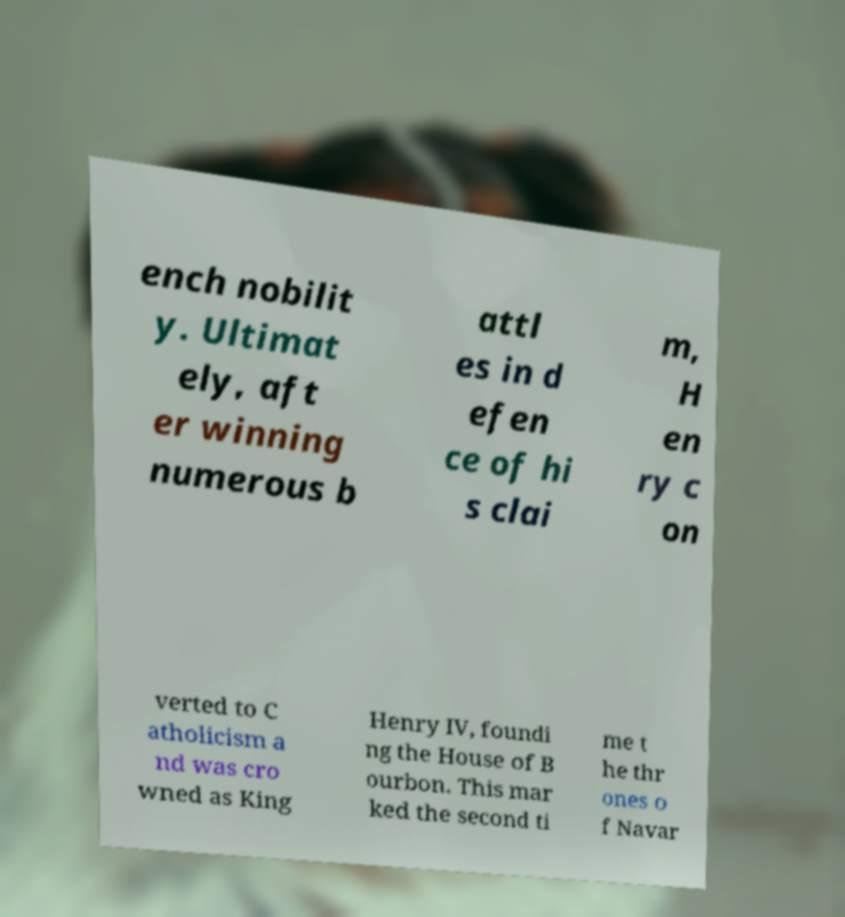There's text embedded in this image that I need extracted. Can you transcribe it verbatim? ench nobilit y. Ultimat ely, aft er winning numerous b attl es in d efen ce of hi s clai m, H en ry c on verted to C atholicism a nd was cro wned as King Henry IV, foundi ng the House of B ourbon. This mar ked the second ti me t he thr ones o f Navar 